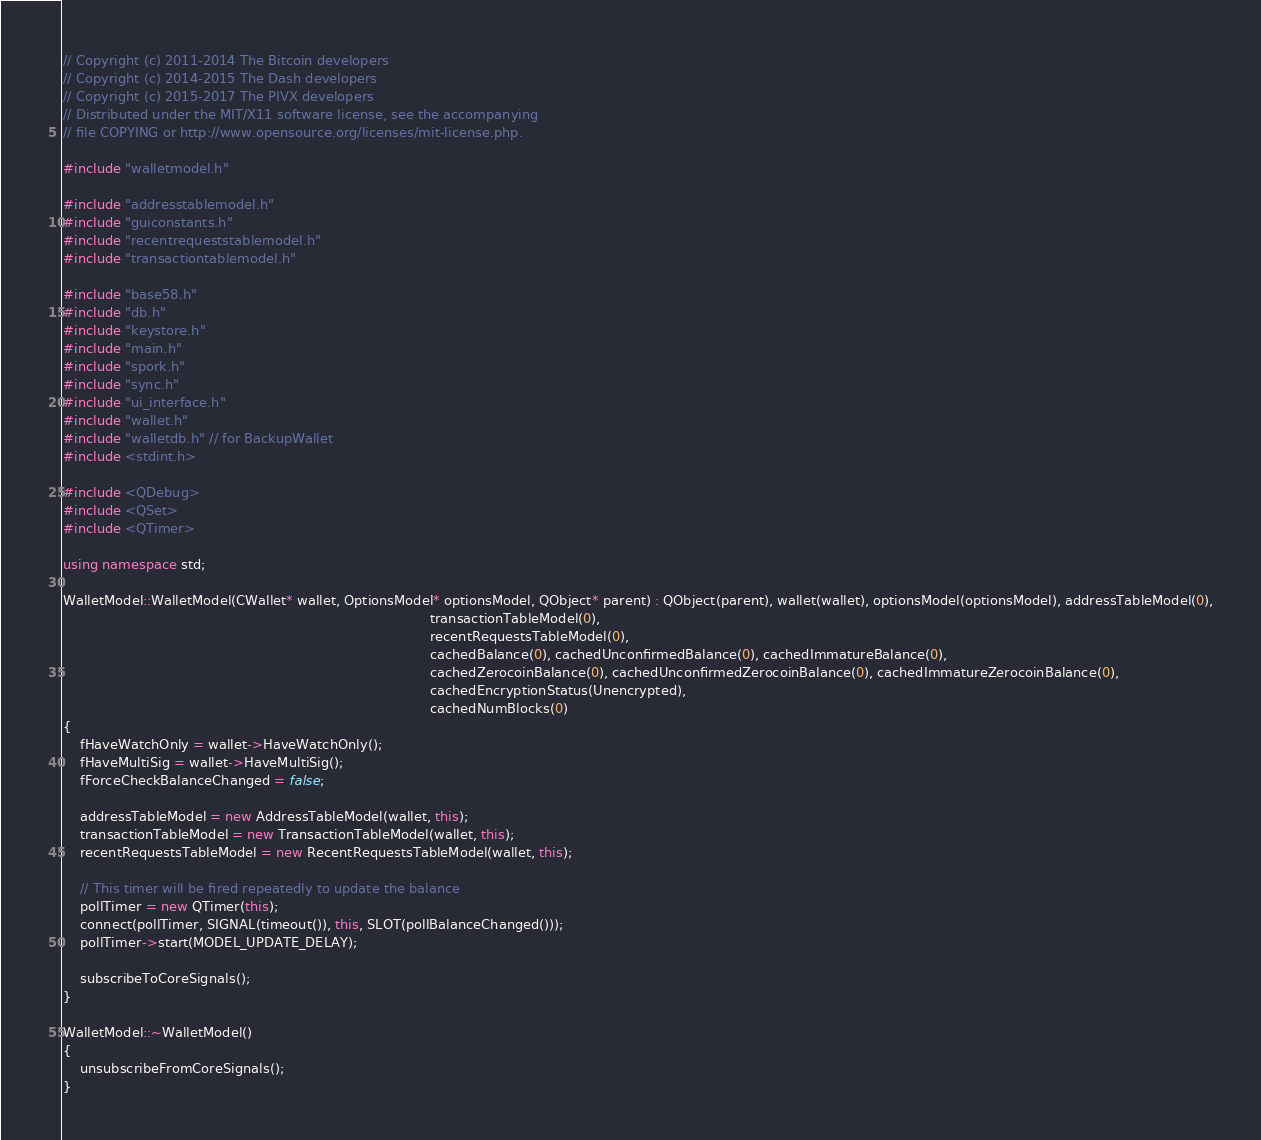<code> <loc_0><loc_0><loc_500><loc_500><_C++_>// Copyright (c) 2011-2014 The Bitcoin developers
// Copyright (c) 2014-2015 The Dash developers
// Copyright (c) 2015-2017 The PIVX developers
// Distributed under the MIT/X11 software license, see the accompanying
// file COPYING or http://www.opensource.org/licenses/mit-license.php.

#include "walletmodel.h"

#include "addresstablemodel.h"
#include "guiconstants.h"
#include "recentrequeststablemodel.h"
#include "transactiontablemodel.h"

#include "base58.h"
#include "db.h"
#include "keystore.h"
#include "main.h"
#include "spork.h"
#include "sync.h"
#include "ui_interface.h"
#include "wallet.h"
#include "walletdb.h" // for BackupWallet
#include <stdint.h>

#include <QDebug>
#include <QSet>
#include <QTimer>

using namespace std;

WalletModel::WalletModel(CWallet* wallet, OptionsModel* optionsModel, QObject* parent) : QObject(parent), wallet(wallet), optionsModel(optionsModel), addressTableModel(0),
                                                                                         transactionTableModel(0),
                                                                                         recentRequestsTableModel(0),
                                                                                         cachedBalance(0), cachedUnconfirmedBalance(0), cachedImmatureBalance(0),
                                                                                         cachedZerocoinBalance(0), cachedUnconfirmedZerocoinBalance(0), cachedImmatureZerocoinBalance(0),
                                                                                         cachedEncryptionStatus(Unencrypted),
                                                                                         cachedNumBlocks(0)
{
    fHaveWatchOnly = wallet->HaveWatchOnly();
    fHaveMultiSig = wallet->HaveMultiSig();
    fForceCheckBalanceChanged = false;

    addressTableModel = new AddressTableModel(wallet, this);
    transactionTableModel = new TransactionTableModel(wallet, this);
    recentRequestsTableModel = new RecentRequestsTableModel(wallet, this);

    // This timer will be fired repeatedly to update the balance
    pollTimer = new QTimer(this);
    connect(pollTimer, SIGNAL(timeout()), this, SLOT(pollBalanceChanged()));
    pollTimer->start(MODEL_UPDATE_DELAY);

    subscribeToCoreSignals();
}

WalletModel::~WalletModel()
{
    unsubscribeFromCoreSignals();
}
</code> 